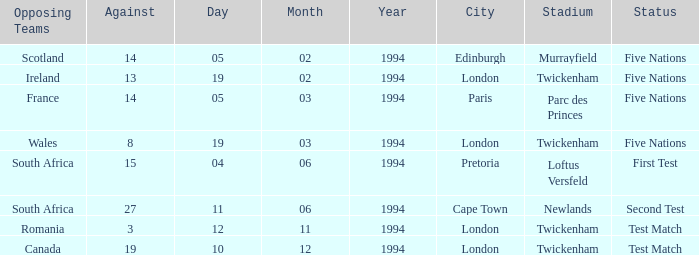Would you be able to parse every entry in this table? {'header': ['Opposing Teams', 'Against', 'Day', 'Month', 'Year', 'City', 'Stadium', 'Status'], 'rows': [['Scotland', '14', '05', '02', '1994', 'Edinburgh', 'Murrayfield', 'Five Nations'], ['Ireland', '13', '19', '02', '1994', 'London', 'Twickenham', 'Five Nations'], ['France', '14', '05', '03', '1994', 'Paris', 'Parc des Princes', 'Five Nations'], ['Wales', '8', '19', '03', '1994', 'London', 'Twickenham', 'Five Nations'], ['South Africa', '15', '04', '06', '1994', 'Pretoria', 'Loftus Versfeld', 'First Test'], ['South Africa', '27', '11', '06', '1994', 'Cape Town', 'Newlands', 'Second Test'], ['Romania', '3', '12', '11', '1994', 'London', 'Twickenham', 'Test Match'], ['Canada', '19', '10', '12', '1994', 'London', 'Twickenham', 'Test Match']]} How many against have a status of first test? 1.0. 